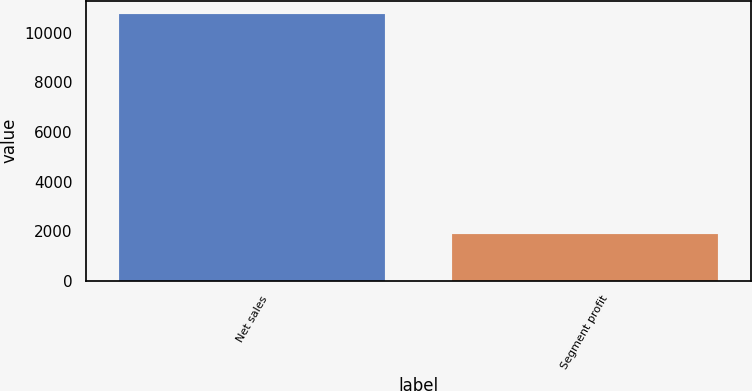Convert chart to OTSL. <chart><loc_0><loc_0><loc_500><loc_500><bar_chart><fcel>Net sales<fcel>Segment profit<nl><fcel>10763<fcel>1893<nl></chart> 